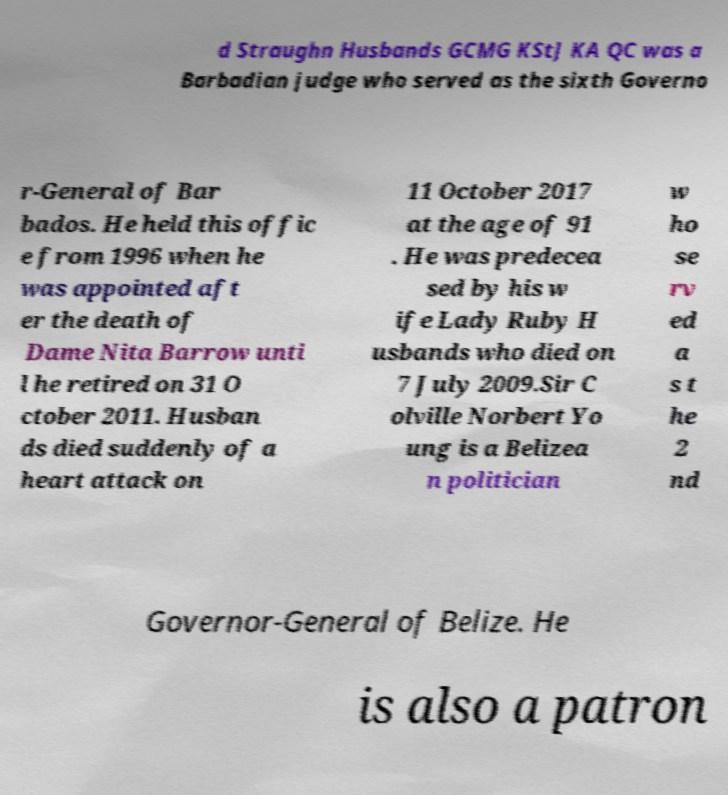For documentation purposes, I need the text within this image transcribed. Could you provide that? d Straughn Husbands GCMG KStJ KA QC was a Barbadian judge who served as the sixth Governo r-General of Bar bados. He held this offic e from 1996 when he was appointed aft er the death of Dame Nita Barrow unti l he retired on 31 O ctober 2011. Husban ds died suddenly of a heart attack on 11 October 2017 at the age of 91 . He was predecea sed by his w ife Lady Ruby H usbands who died on 7 July 2009.Sir C olville Norbert Yo ung is a Belizea n politician w ho se rv ed a s t he 2 nd Governor-General of Belize. He is also a patron 